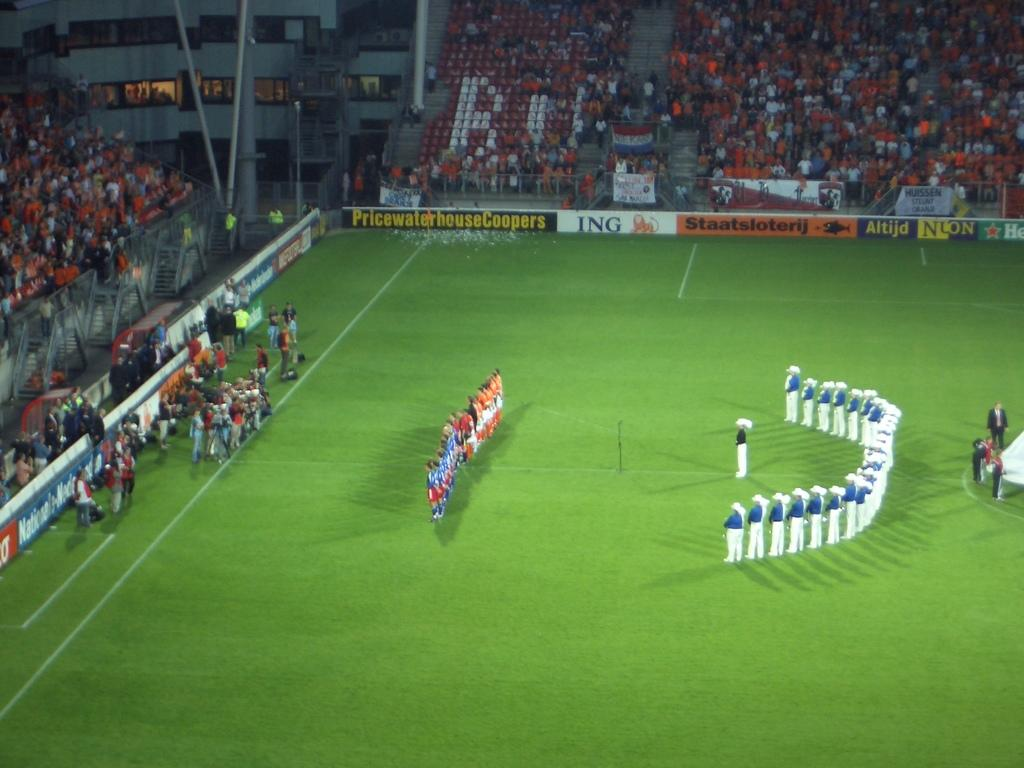<image>
Describe the image concisely. A sign advertises PriceWaterhouseCoopers alongside a ball field. 